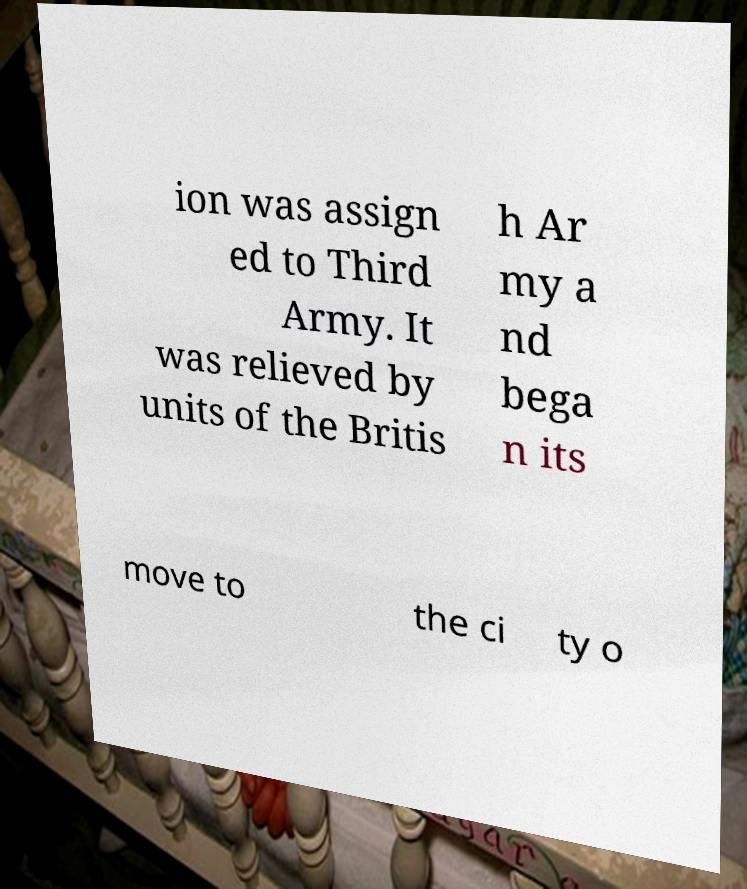Please identify and transcribe the text found in this image. ion was assign ed to Third Army. It was relieved by units of the Britis h Ar my a nd bega n its move to the ci ty o 